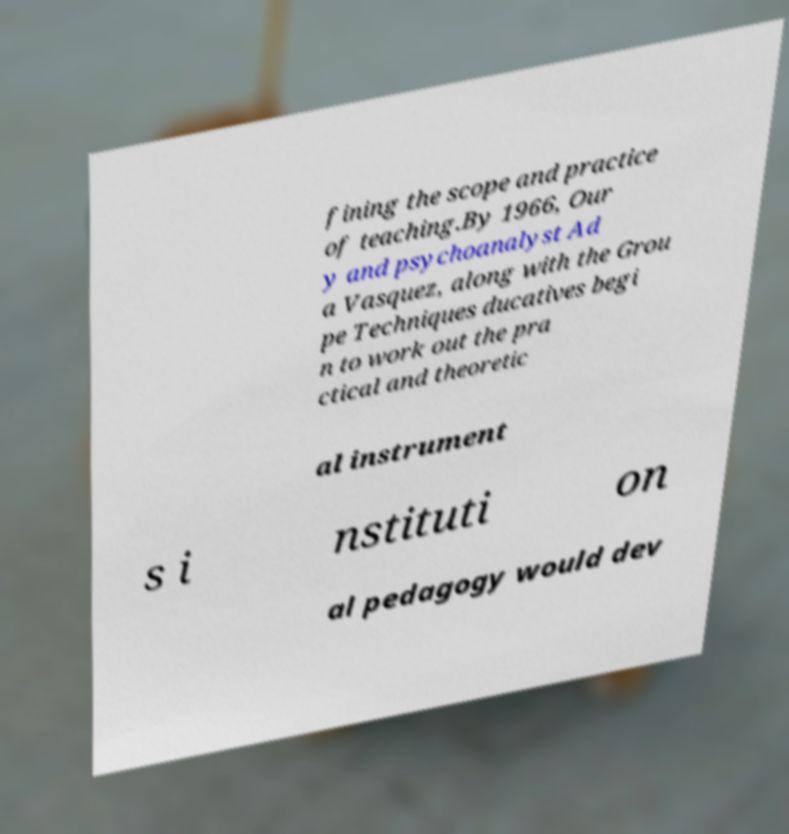I need the written content from this picture converted into text. Can you do that? fining the scope and practice of teaching.By 1966, Our y and psychoanalyst Ad a Vasquez, along with the Grou pe Techniques ducatives begi n to work out the pra ctical and theoretic al instrument s i nstituti on al pedagogy would dev 